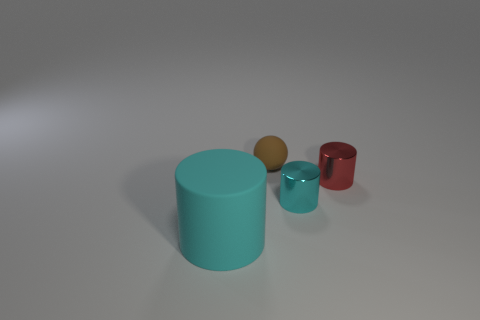There is a red shiny object; does it have the same size as the shiny cylinder in front of the small red metal object?
Make the answer very short. Yes. Is there any other thing that has the same shape as the brown rubber thing?
Your answer should be very brief. No. What is the color of the other tiny metallic thing that is the same shape as the red metal thing?
Your answer should be very brief. Cyan. Do the red metallic cylinder and the matte cylinder have the same size?
Your answer should be compact. No. How many other objects are the same size as the brown rubber thing?
Offer a very short reply. 2. How many things are either tiny things that are on the right side of the tiny cyan cylinder or rubber things that are behind the large cyan cylinder?
Your answer should be very brief. 2. What shape is the brown thing that is the same size as the red metal thing?
Make the answer very short. Sphere. What size is the thing that is made of the same material as the ball?
Give a very brief answer. Large. Is the shape of the tiny cyan thing the same as the red thing?
Provide a short and direct response. Yes. There is a metal cylinder that is the same size as the red object; what color is it?
Offer a very short reply. Cyan. 